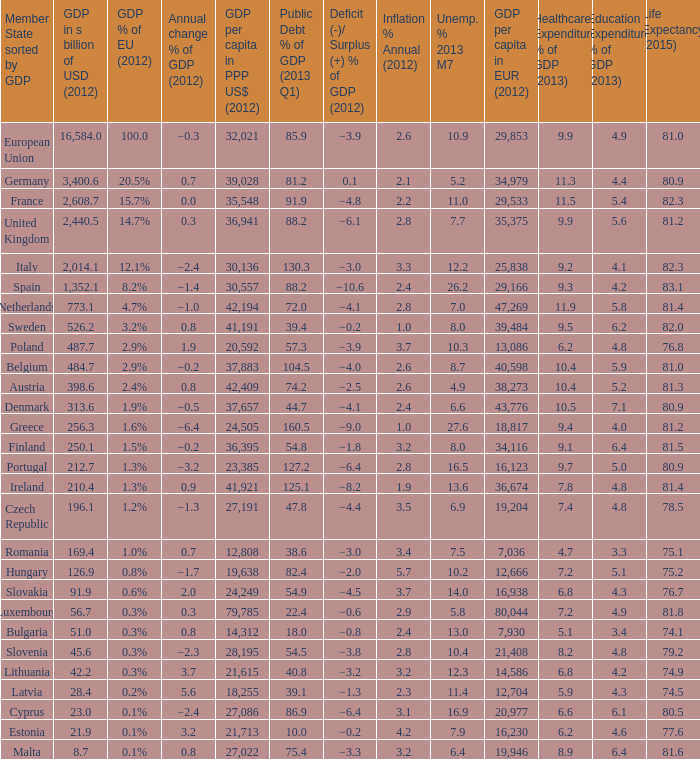What is the average public debt % of GDP in 2013 Q1 of the country with a member slate sorted by GDP of Czech Republic and a GDP per capita in PPP US dollars in 2012 greater than 27,191? None. 